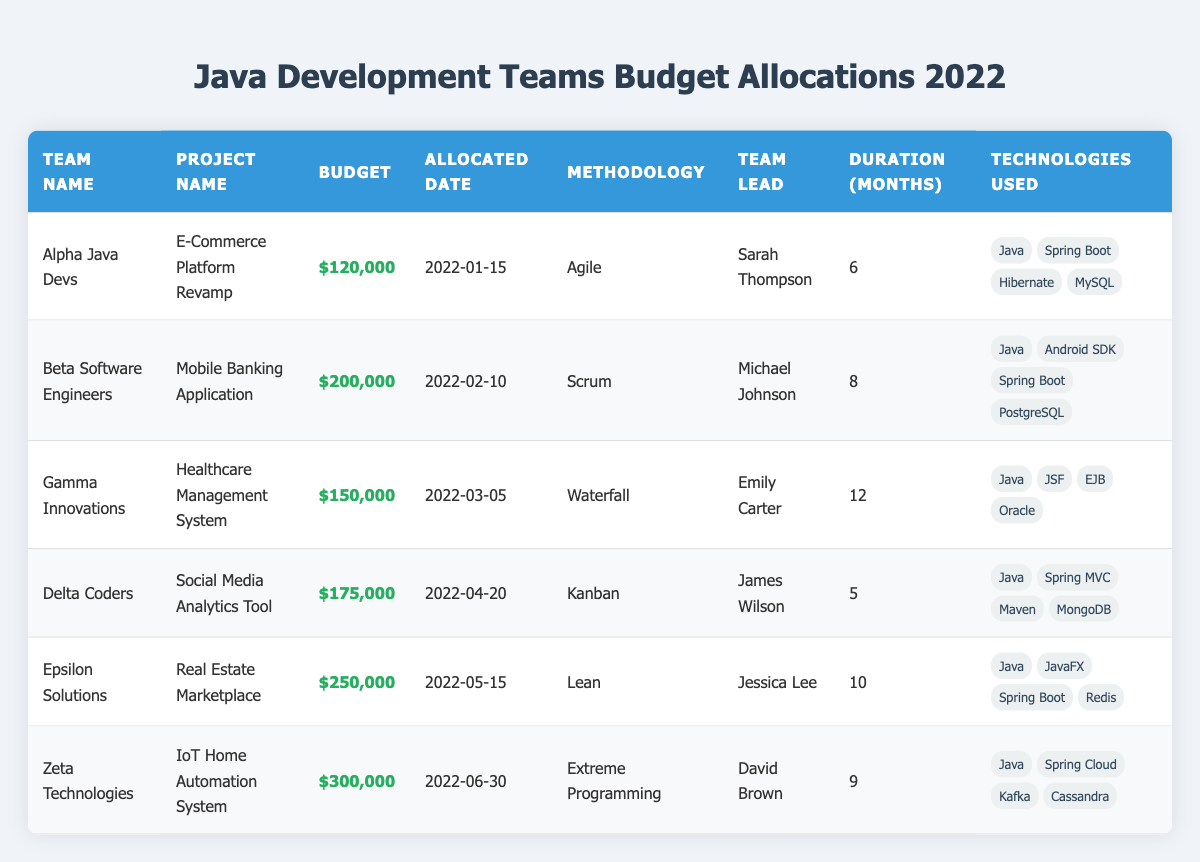What is the budget allocated for the project "E-Commerce Platform Revamp"? The budget for "E-Commerce Platform Revamp" is listed in the row for "Alpha Java Devs" under the "Budget" column, which shows $120,000.
Answer: $120,000 Who is the team lead for the project "Healthcare Management System"? The team lead for "Healthcare Management System" is specified in the row corresponding to "Gamma Innovations," which lists Emily Carter as the team lead.
Answer: Emily Carter Which project has the highest budget allocation? To determine which project has the highest budget, we can compare the budgets of all projects: $120,000, $200,000, $150,000, $175,000, $250,000, and $300,000. The highest budget is $300,000 for the "IoT Home Automation System."
Answer: $300,000 How many months is the project "Social Media Analytics Tool" planned to last? In the row for "Delta Coders," the "Duration (Months)" column indicates that the "Social Media Analytics Tool" is planned for 5 months.
Answer: 5 Is the "Mobile Banking Application" developed using Java? Looking at the row for "Beta Software Engineers," the technologies used for the "Mobile Banking Application" include Java, among others. Therefore, the answer is yes.
Answer: Yes What is the average budget of all the projects listed? To find the average budget, first sum all the budgets: $120,000 + $200,000 + $150,000 + $175,000 + $250,000 + $300,000 = $1,195,000. There are 6 projects, so the average budget is $1,195,000 divided by 6, which equals approximately $199,167.
Answer: $199,167 Which methodology is used for the "Real Estate Marketplace" project? The methodology used for the "Real Estate Marketplace" is noted in the row for "Epsilon Solutions," which states the methodology is Lean.
Answer: Lean How many projects last for more than 8 months? By examining the duration for each project: 6 months, 8 months, 12 months, 5 months, 10 months, and 9 months, we can see that 3 projects (Healthcare Management System, Real Estate Marketplace, and IoT Home Automation System) last longer than 8 months.
Answer: 3 What technologies are used in the "IoT Home Automation System"? The technologies used for the "IoT Home Automation System," as noted in the row for "Zeta Technologies," include Java, Spring Cloud, Kafka, and Cassandra.
Answer: Java, Spring Cloud, Kafka, Cassandra 